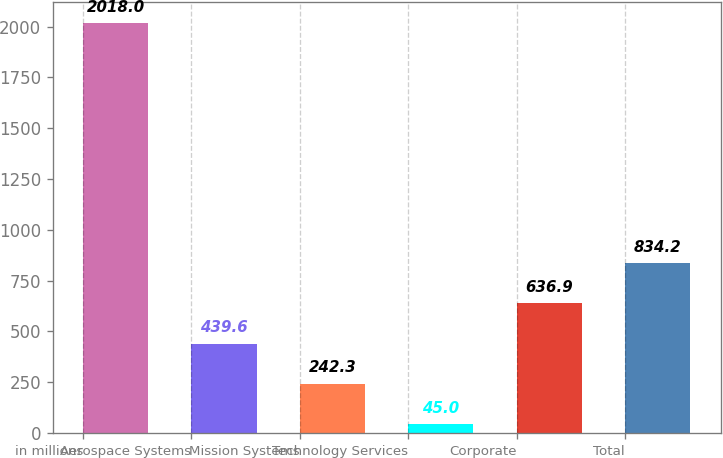Convert chart to OTSL. <chart><loc_0><loc_0><loc_500><loc_500><bar_chart><fcel>in millions<fcel>Aerospace Systems<fcel>Mission Systems<fcel>Technology Services<fcel>Corporate<fcel>Total<nl><fcel>2018<fcel>439.6<fcel>242.3<fcel>45<fcel>636.9<fcel>834.2<nl></chart> 